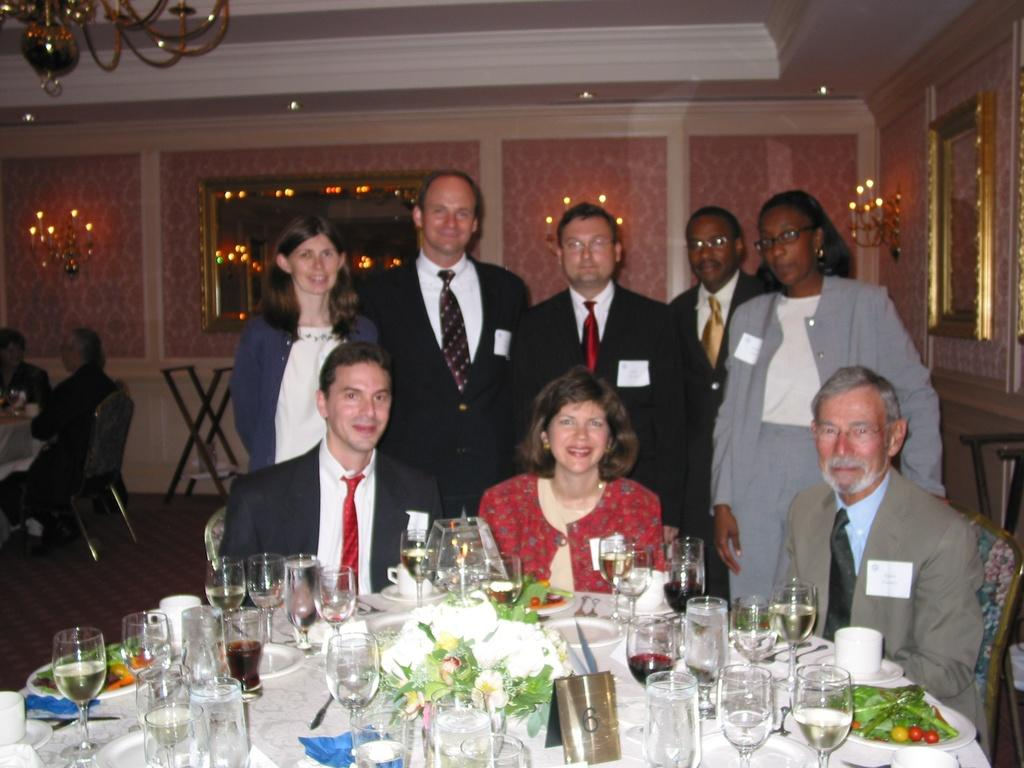How many people are sitting in the image? There are three people sitting in the image. What can be found on the table in the image? There is a glass, a plate, and food on the table. How many people are standing in the image? There are five people standing at the back side of the image. What is hanging on the wall in the image? There is a frame on the wall. What color are the eyes of the person sitting in the middle in the image? The image does not provide information about the eye color of the people sitting or standing. --- 